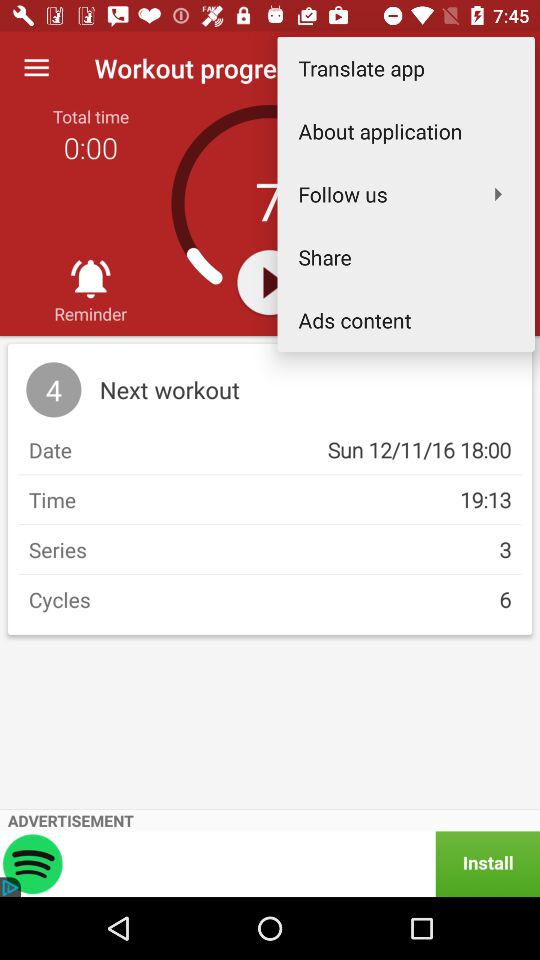What's the number of series? The number of series is 3. 